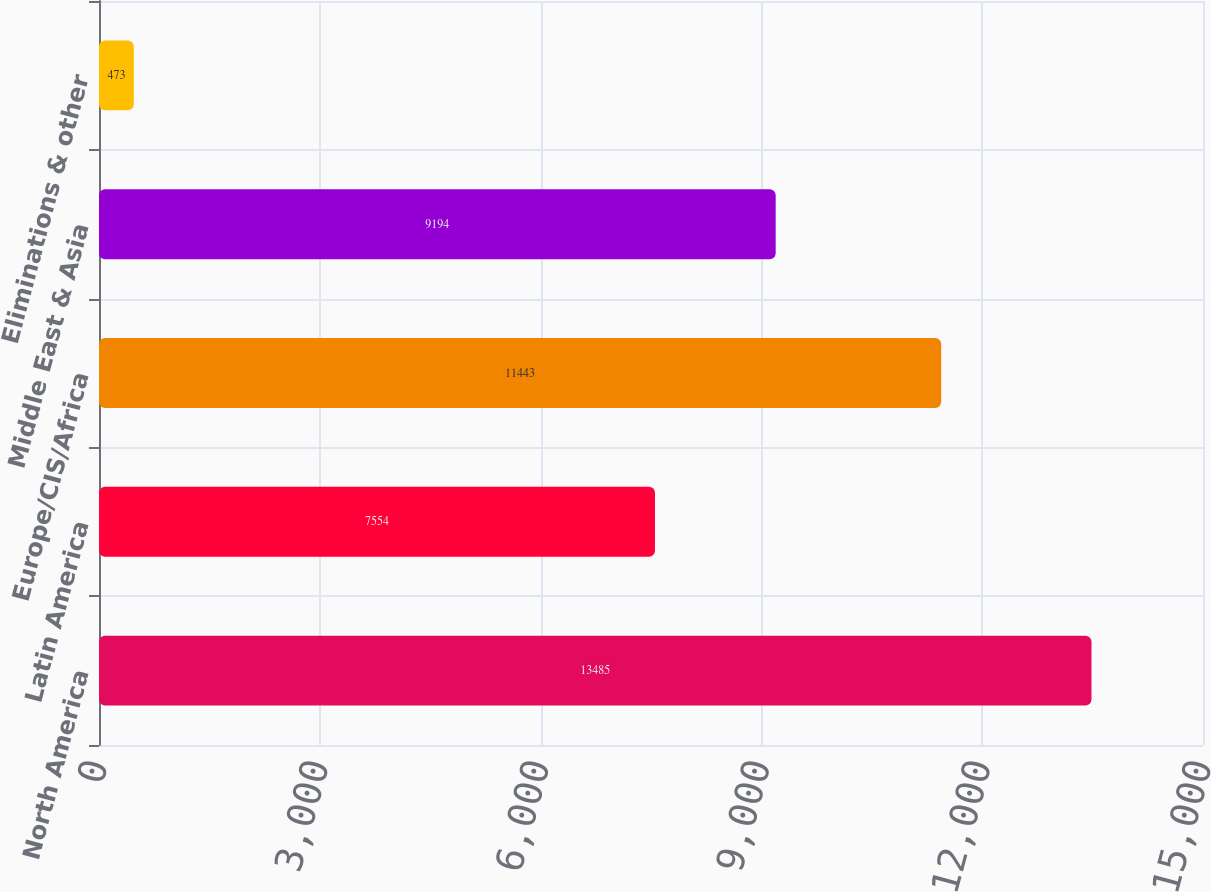<chart> <loc_0><loc_0><loc_500><loc_500><bar_chart><fcel>North America<fcel>Latin America<fcel>Europe/CIS/Africa<fcel>Middle East & Asia<fcel>Eliminations & other<nl><fcel>13485<fcel>7554<fcel>11443<fcel>9194<fcel>473<nl></chart> 